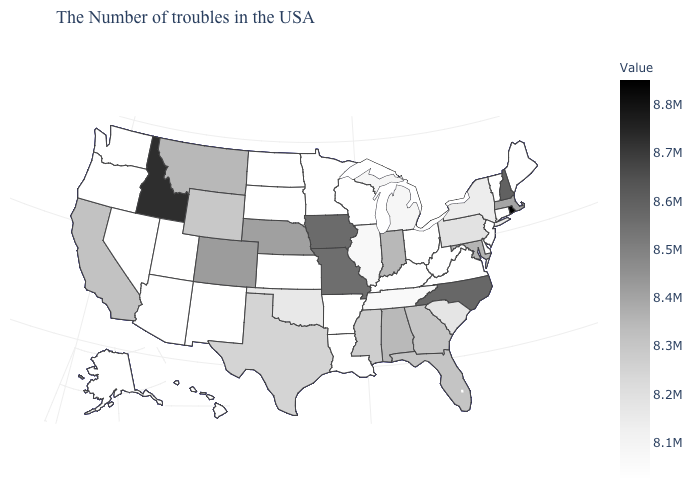Among the states that border Virginia , which have the lowest value?
Answer briefly. West Virginia, Kentucky. Is the legend a continuous bar?
Give a very brief answer. Yes. Does California have the lowest value in the West?
Short answer required. No. Does Maine have the lowest value in the Northeast?
Keep it brief. Yes. Which states have the lowest value in the USA?
Answer briefly. Maine, Vermont, New Jersey, Delaware, Virginia, West Virginia, Ohio, Kentucky, Wisconsin, Louisiana, Arkansas, Minnesota, Kansas, South Dakota, North Dakota, New Mexico, Utah, Arizona, Nevada, Washington, Oregon, Alaska, Hawaii. Does Idaho have the highest value in the West?
Be succinct. Yes. Which states have the lowest value in the MidWest?
Write a very short answer. Ohio, Wisconsin, Minnesota, Kansas, South Dakota, North Dakota. 